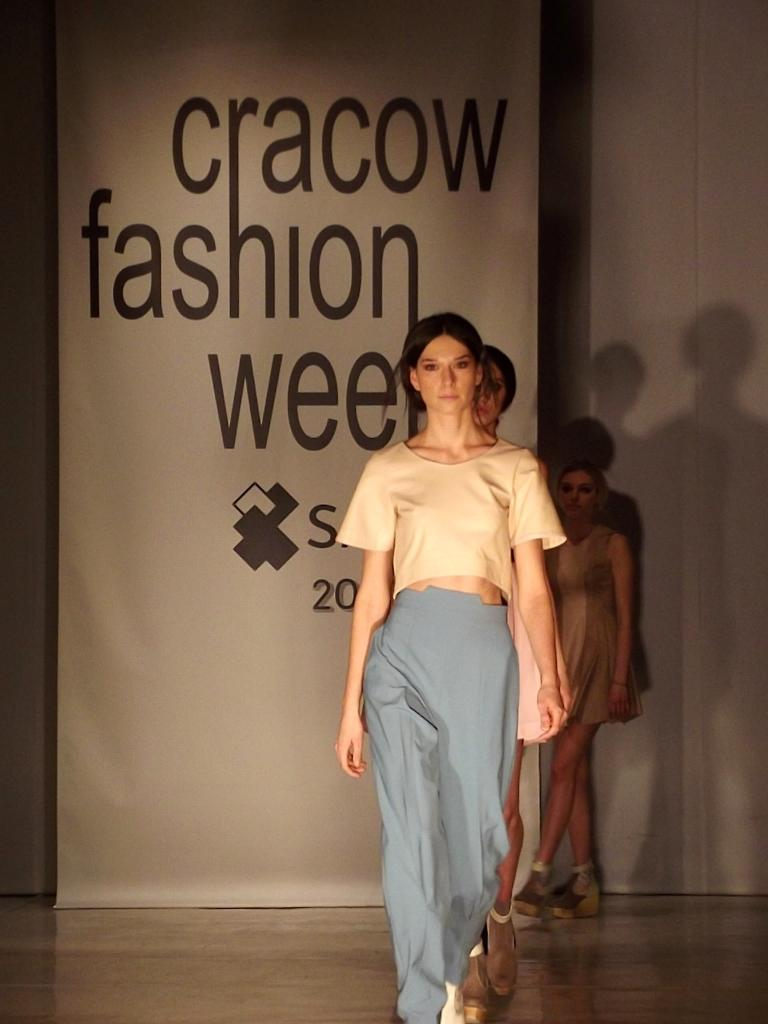How many women are in the image? There are women in the image. What are the women wearing? The women are wearing different color dresses. What are the women doing in the image? The women are moonwalking in a line. Where are the women located in the image? The women are on the floor. What can be seen in the background of the image? There is a white color hoarding and a white wall in the background. What type of beetle can be seen crawling on the women's dresses in the image? There are no beetles present in the image; the women are moonwalking in a line while wearing different color dresses. How many balls are visible in the image? There are no balls present in the image; the focus is on the women who are moonwalking in a line while wearing different color dresses. 